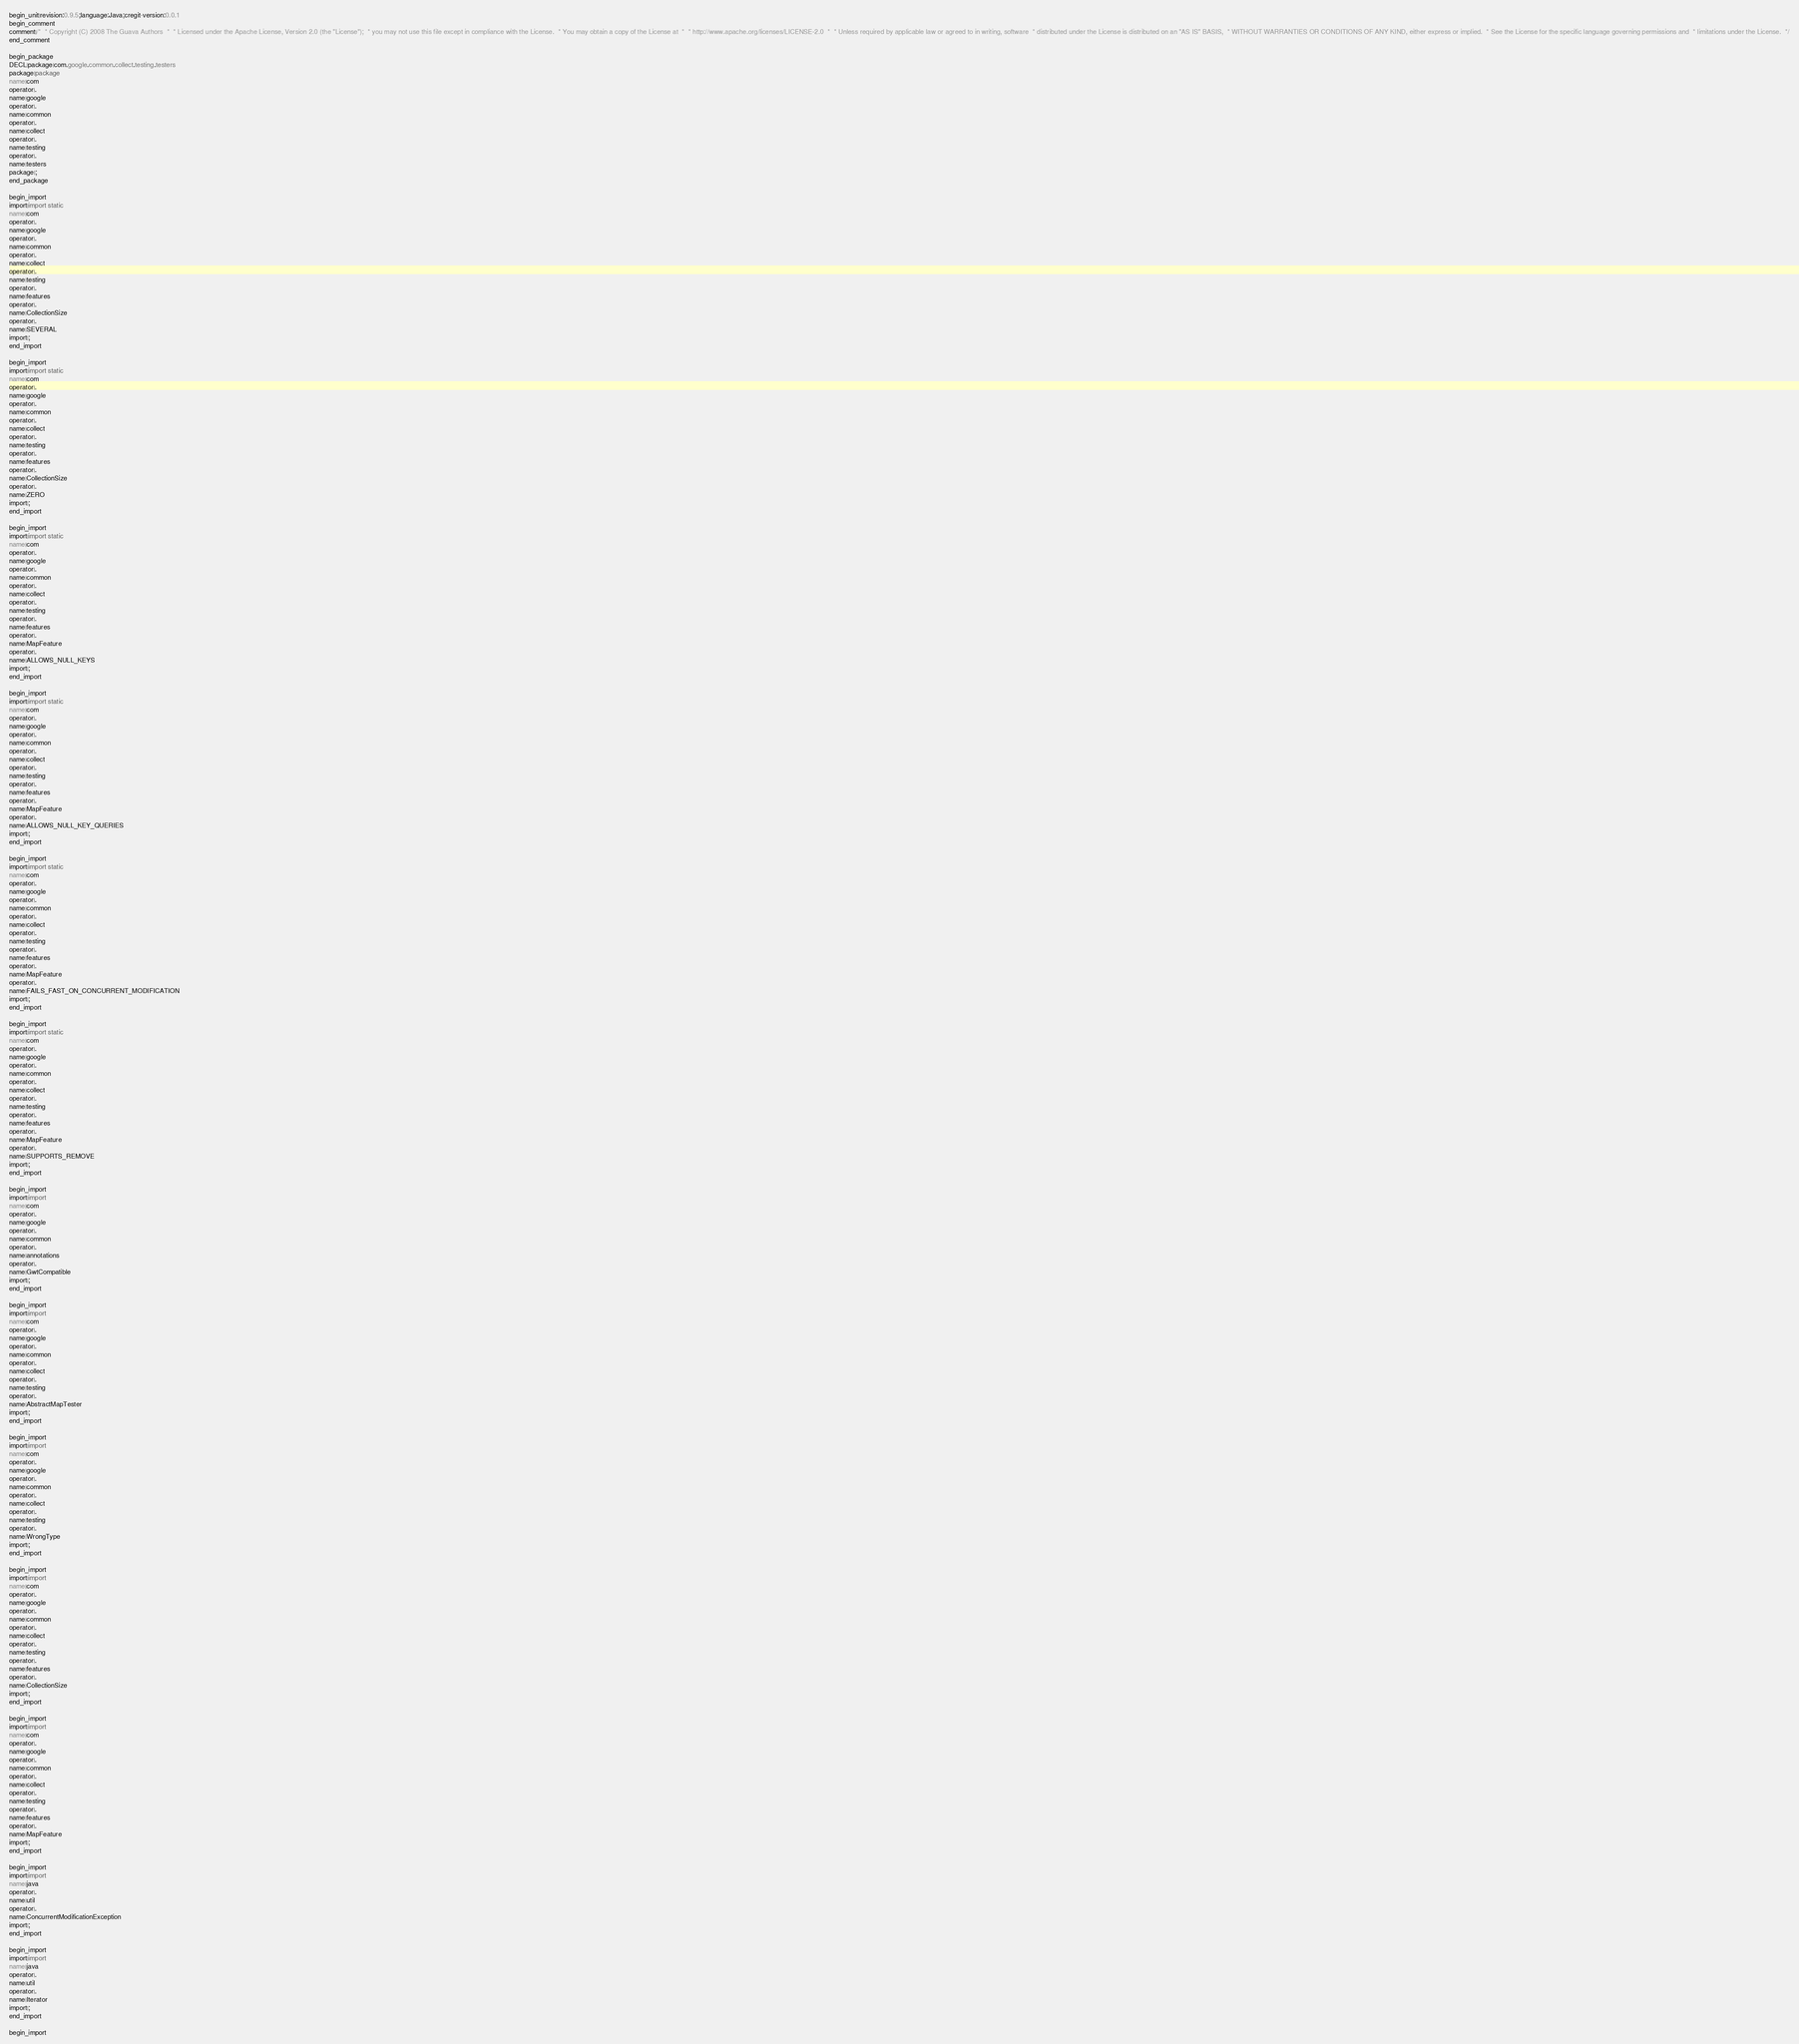<code> <loc_0><loc_0><loc_500><loc_500><_Java_>begin_unit|revision:0.9.5;language:Java;cregit-version:0.0.1
begin_comment
comment|/*  * Copyright (C) 2008 The Guava Authors  *  * Licensed under the Apache License, Version 2.0 (the "License");  * you may not use this file except in compliance with the License.  * You may obtain a copy of the License at  *  * http://www.apache.org/licenses/LICENSE-2.0  *  * Unless required by applicable law or agreed to in writing, software  * distributed under the License is distributed on an "AS IS" BASIS,  * WITHOUT WARRANTIES OR CONDITIONS OF ANY KIND, either express or implied.  * See the License for the specific language governing permissions and  * limitations under the License.  */
end_comment

begin_package
DECL|package|com.google.common.collect.testing.testers
package|package
name|com
operator|.
name|google
operator|.
name|common
operator|.
name|collect
operator|.
name|testing
operator|.
name|testers
package|;
end_package

begin_import
import|import static
name|com
operator|.
name|google
operator|.
name|common
operator|.
name|collect
operator|.
name|testing
operator|.
name|features
operator|.
name|CollectionSize
operator|.
name|SEVERAL
import|;
end_import

begin_import
import|import static
name|com
operator|.
name|google
operator|.
name|common
operator|.
name|collect
operator|.
name|testing
operator|.
name|features
operator|.
name|CollectionSize
operator|.
name|ZERO
import|;
end_import

begin_import
import|import static
name|com
operator|.
name|google
operator|.
name|common
operator|.
name|collect
operator|.
name|testing
operator|.
name|features
operator|.
name|MapFeature
operator|.
name|ALLOWS_NULL_KEYS
import|;
end_import

begin_import
import|import static
name|com
operator|.
name|google
operator|.
name|common
operator|.
name|collect
operator|.
name|testing
operator|.
name|features
operator|.
name|MapFeature
operator|.
name|ALLOWS_NULL_KEY_QUERIES
import|;
end_import

begin_import
import|import static
name|com
operator|.
name|google
operator|.
name|common
operator|.
name|collect
operator|.
name|testing
operator|.
name|features
operator|.
name|MapFeature
operator|.
name|FAILS_FAST_ON_CONCURRENT_MODIFICATION
import|;
end_import

begin_import
import|import static
name|com
operator|.
name|google
operator|.
name|common
operator|.
name|collect
operator|.
name|testing
operator|.
name|features
operator|.
name|MapFeature
operator|.
name|SUPPORTS_REMOVE
import|;
end_import

begin_import
import|import
name|com
operator|.
name|google
operator|.
name|common
operator|.
name|annotations
operator|.
name|GwtCompatible
import|;
end_import

begin_import
import|import
name|com
operator|.
name|google
operator|.
name|common
operator|.
name|collect
operator|.
name|testing
operator|.
name|AbstractMapTester
import|;
end_import

begin_import
import|import
name|com
operator|.
name|google
operator|.
name|common
operator|.
name|collect
operator|.
name|testing
operator|.
name|WrongType
import|;
end_import

begin_import
import|import
name|com
operator|.
name|google
operator|.
name|common
operator|.
name|collect
operator|.
name|testing
operator|.
name|features
operator|.
name|CollectionSize
import|;
end_import

begin_import
import|import
name|com
operator|.
name|google
operator|.
name|common
operator|.
name|collect
operator|.
name|testing
operator|.
name|features
operator|.
name|MapFeature
import|;
end_import

begin_import
import|import
name|java
operator|.
name|util
operator|.
name|ConcurrentModificationException
import|;
end_import

begin_import
import|import
name|java
operator|.
name|util
operator|.
name|Iterator
import|;
end_import

begin_import</code> 